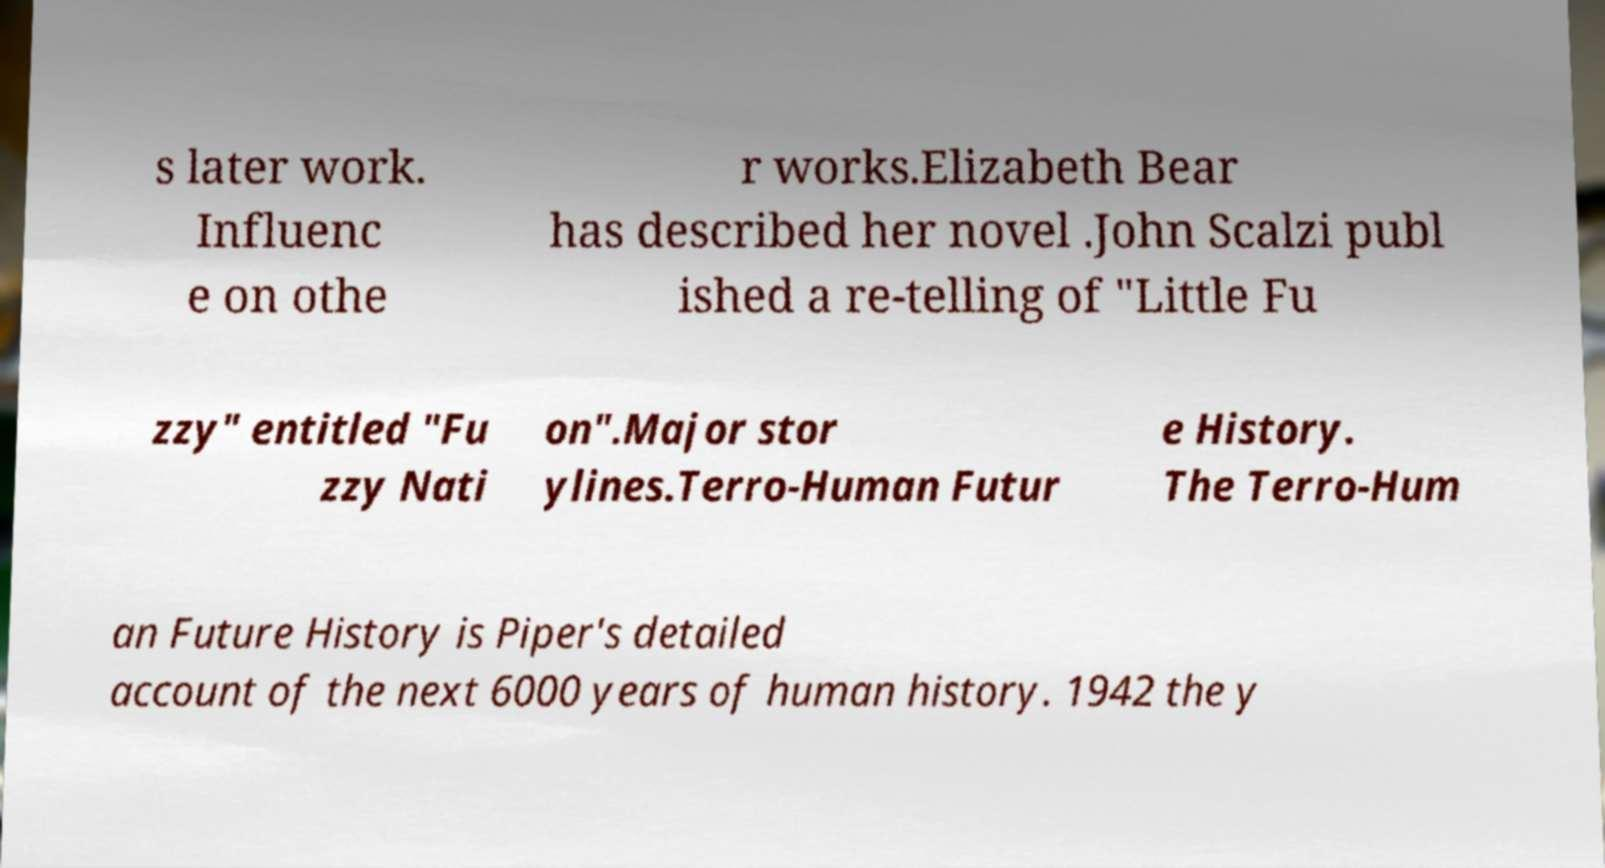Can you read and provide the text displayed in the image?This photo seems to have some interesting text. Can you extract and type it out for me? s later work. Influenc e on othe r works.Elizabeth Bear has described her novel .John Scalzi publ ished a re-telling of "Little Fu zzy" entitled "Fu zzy Nati on".Major stor ylines.Terro-Human Futur e History. The Terro-Hum an Future History is Piper's detailed account of the next 6000 years of human history. 1942 the y 